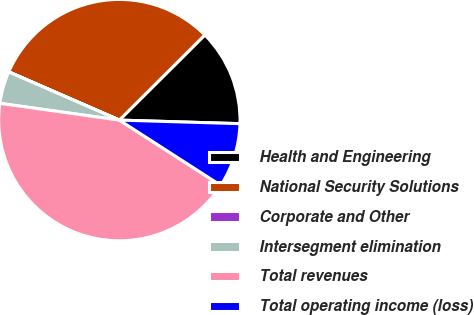Convert chart. <chart><loc_0><loc_0><loc_500><loc_500><pie_chart><fcel>Health and Engineering<fcel>National Security Solutions<fcel>Corporate and Other<fcel>Intersegment elimination<fcel>Total revenues<fcel>Total operating income (loss)<nl><fcel>12.94%<fcel>30.99%<fcel>0.01%<fcel>4.32%<fcel>43.12%<fcel>8.63%<nl></chart> 